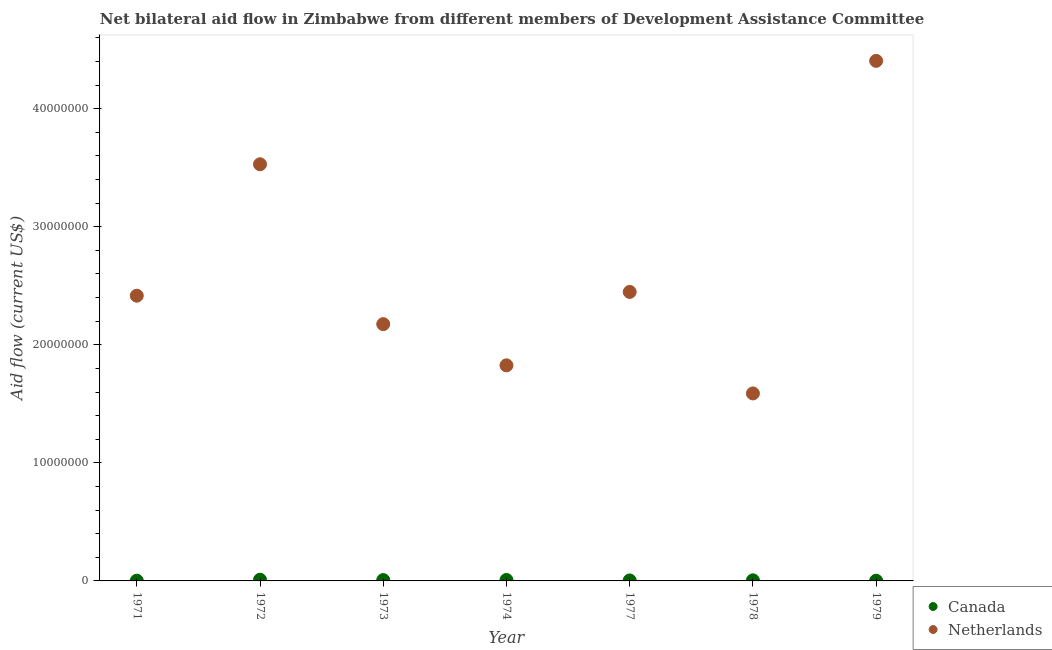What is the amount of aid given by netherlands in 1974?
Give a very brief answer. 1.83e+07. Across all years, what is the maximum amount of aid given by netherlands?
Ensure brevity in your answer.  4.40e+07. Across all years, what is the minimum amount of aid given by netherlands?
Provide a succinct answer. 1.59e+07. In which year was the amount of aid given by canada maximum?
Give a very brief answer. 1972. In which year was the amount of aid given by canada minimum?
Offer a terse response. 1971. What is the total amount of aid given by canada in the graph?
Provide a short and direct response. 3.80e+05. What is the difference between the amount of aid given by canada in 1972 and that in 1973?
Ensure brevity in your answer.  3.00e+04. What is the difference between the amount of aid given by netherlands in 1978 and the amount of aid given by canada in 1971?
Give a very brief answer. 1.59e+07. What is the average amount of aid given by canada per year?
Make the answer very short. 5.43e+04. In the year 1972, what is the difference between the amount of aid given by netherlands and amount of aid given by canada?
Provide a succinct answer. 3.52e+07. In how many years, is the amount of aid given by canada greater than 14000000 US$?
Your response must be concise. 0. What is the ratio of the amount of aid given by netherlands in 1971 to that in 1974?
Your answer should be compact. 1.32. Is the amount of aid given by netherlands in 1971 less than that in 1979?
Your response must be concise. Yes. What is the difference between the highest and the second highest amount of aid given by netherlands?
Your answer should be compact. 8.76e+06. What is the difference between the highest and the lowest amount of aid given by netherlands?
Provide a succinct answer. 2.82e+07. In how many years, is the amount of aid given by netherlands greater than the average amount of aid given by netherlands taken over all years?
Offer a very short reply. 2. Is the sum of the amount of aid given by canada in 1973 and 1977 greater than the maximum amount of aid given by netherlands across all years?
Provide a short and direct response. No. Does the amount of aid given by canada monotonically increase over the years?
Your answer should be very brief. No. Is the amount of aid given by netherlands strictly greater than the amount of aid given by canada over the years?
Provide a short and direct response. Yes. Is the amount of aid given by netherlands strictly less than the amount of aid given by canada over the years?
Your answer should be compact. No. How many dotlines are there?
Offer a terse response. 2. Where does the legend appear in the graph?
Offer a terse response. Bottom right. How many legend labels are there?
Keep it short and to the point. 2. What is the title of the graph?
Offer a very short reply. Net bilateral aid flow in Zimbabwe from different members of Development Assistance Committee. Does "Female" appear as one of the legend labels in the graph?
Keep it short and to the point. No. What is the Aid flow (current US$) of Canada in 1971?
Your answer should be compact. 2.00e+04. What is the Aid flow (current US$) of Netherlands in 1971?
Provide a succinct answer. 2.42e+07. What is the Aid flow (current US$) in Netherlands in 1972?
Provide a short and direct response. 3.53e+07. What is the Aid flow (current US$) in Canada in 1973?
Offer a terse response. 7.00e+04. What is the Aid flow (current US$) of Netherlands in 1973?
Your response must be concise. 2.18e+07. What is the Aid flow (current US$) of Netherlands in 1974?
Offer a very short reply. 1.83e+07. What is the Aid flow (current US$) in Canada in 1977?
Offer a terse response. 4.00e+04. What is the Aid flow (current US$) in Netherlands in 1977?
Offer a terse response. 2.45e+07. What is the Aid flow (current US$) of Netherlands in 1978?
Provide a short and direct response. 1.59e+07. What is the Aid flow (current US$) of Canada in 1979?
Provide a succinct answer. 2.00e+04. What is the Aid flow (current US$) of Netherlands in 1979?
Give a very brief answer. 4.40e+07. Across all years, what is the maximum Aid flow (current US$) of Netherlands?
Make the answer very short. 4.40e+07. Across all years, what is the minimum Aid flow (current US$) in Netherlands?
Provide a short and direct response. 1.59e+07. What is the total Aid flow (current US$) in Netherlands in the graph?
Keep it short and to the point. 1.84e+08. What is the difference between the Aid flow (current US$) of Canada in 1971 and that in 1972?
Provide a succinct answer. -8.00e+04. What is the difference between the Aid flow (current US$) of Netherlands in 1971 and that in 1972?
Your answer should be compact. -1.11e+07. What is the difference between the Aid flow (current US$) in Netherlands in 1971 and that in 1973?
Offer a terse response. 2.41e+06. What is the difference between the Aid flow (current US$) of Netherlands in 1971 and that in 1974?
Your response must be concise. 5.90e+06. What is the difference between the Aid flow (current US$) of Canada in 1971 and that in 1977?
Offer a terse response. -2.00e+04. What is the difference between the Aid flow (current US$) in Netherlands in 1971 and that in 1977?
Keep it short and to the point. -3.20e+05. What is the difference between the Aid flow (current US$) in Netherlands in 1971 and that in 1978?
Your answer should be compact. 8.28e+06. What is the difference between the Aid flow (current US$) in Canada in 1971 and that in 1979?
Make the answer very short. 0. What is the difference between the Aid flow (current US$) of Netherlands in 1971 and that in 1979?
Your response must be concise. -1.99e+07. What is the difference between the Aid flow (current US$) of Netherlands in 1972 and that in 1973?
Make the answer very short. 1.35e+07. What is the difference between the Aid flow (current US$) of Canada in 1972 and that in 1974?
Provide a succinct answer. 2.00e+04. What is the difference between the Aid flow (current US$) of Netherlands in 1972 and that in 1974?
Provide a succinct answer. 1.70e+07. What is the difference between the Aid flow (current US$) of Netherlands in 1972 and that in 1977?
Offer a terse response. 1.08e+07. What is the difference between the Aid flow (current US$) of Canada in 1972 and that in 1978?
Your response must be concise. 5.00e+04. What is the difference between the Aid flow (current US$) in Netherlands in 1972 and that in 1978?
Ensure brevity in your answer.  1.94e+07. What is the difference between the Aid flow (current US$) in Canada in 1972 and that in 1979?
Your response must be concise. 8.00e+04. What is the difference between the Aid flow (current US$) in Netherlands in 1972 and that in 1979?
Your response must be concise. -8.76e+06. What is the difference between the Aid flow (current US$) in Netherlands in 1973 and that in 1974?
Ensure brevity in your answer.  3.49e+06. What is the difference between the Aid flow (current US$) in Canada in 1973 and that in 1977?
Keep it short and to the point. 3.00e+04. What is the difference between the Aid flow (current US$) in Netherlands in 1973 and that in 1977?
Keep it short and to the point. -2.73e+06. What is the difference between the Aid flow (current US$) of Netherlands in 1973 and that in 1978?
Your answer should be compact. 5.87e+06. What is the difference between the Aid flow (current US$) in Netherlands in 1973 and that in 1979?
Your answer should be compact. -2.23e+07. What is the difference between the Aid flow (current US$) in Canada in 1974 and that in 1977?
Provide a short and direct response. 4.00e+04. What is the difference between the Aid flow (current US$) in Netherlands in 1974 and that in 1977?
Provide a short and direct response. -6.22e+06. What is the difference between the Aid flow (current US$) in Canada in 1974 and that in 1978?
Ensure brevity in your answer.  3.00e+04. What is the difference between the Aid flow (current US$) of Netherlands in 1974 and that in 1978?
Ensure brevity in your answer.  2.38e+06. What is the difference between the Aid flow (current US$) of Canada in 1974 and that in 1979?
Provide a succinct answer. 6.00e+04. What is the difference between the Aid flow (current US$) in Netherlands in 1974 and that in 1979?
Your answer should be very brief. -2.58e+07. What is the difference between the Aid flow (current US$) in Netherlands in 1977 and that in 1978?
Your answer should be very brief. 8.60e+06. What is the difference between the Aid flow (current US$) of Canada in 1977 and that in 1979?
Make the answer very short. 2.00e+04. What is the difference between the Aid flow (current US$) in Netherlands in 1977 and that in 1979?
Offer a terse response. -1.96e+07. What is the difference between the Aid flow (current US$) of Netherlands in 1978 and that in 1979?
Make the answer very short. -2.82e+07. What is the difference between the Aid flow (current US$) in Canada in 1971 and the Aid flow (current US$) in Netherlands in 1972?
Provide a short and direct response. -3.53e+07. What is the difference between the Aid flow (current US$) of Canada in 1971 and the Aid flow (current US$) of Netherlands in 1973?
Your answer should be very brief. -2.17e+07. What is the difference between the Aid flow (current US$) of Canada in 1971 and the Aid flow (current US$) of Netherlands in 1974?
Offer a terse response. -1.82e+07. What is the difference between the Aid flow (current US$) in Canada in 1971 and the Aid flow (current US$) in Netherlands in 1977?
Your response must be concise. -2.45e+07. What is the difference between the Aid flow (current US$) in Canada in 1971 and the Aid flow (current US$) in Netherlands in 1978?
Make the answer very short. -1.59e+07. What is the difference between the Aid flow (current US$) in Canada in 1971 and the Aid flow (current US$) in Netherlands in 1979?
Your response must be concise. -4.40e+07. What is the difference between the Aid flow (current US$) of Canada in 1972 and the Aid flow (current US$) of Netherlands in 1973?
Provide a succinct answer. -2.16e+07. What is the difference between the Aid flow (current US$) in Canada in 1972 and the Aid flow (current US$) in Netherlands in 1974?
Provide a succinct answer. -1.82e+07. What is the difference between the Aid flow (current US$) of Canada in 1972 and the Aid flow (current US$) of Netherlands in 1977?
Provide a succinct answer. -2.44e+07. What is the difference between the Aid flow (current US$) in Canada in 1972 and the Aid flow (current US$) in Netherlands in 1978?
Provide a succinct answer. -1.58e+07. What is the difference between the Aid flow (current US$) in Canada in 1972 and the Aid flow (current US$) in Netherlands in 1979?
Provide a short and direct response. -4.40e+07. What is the difference between the Aid flow (current US$) of Canada in 1973 and the Aid flow (current US$) of Netherlands in 1974?
Ensure brevity in your answer.  -1.82e+07. What is the difference between the Aid flow (current US$) in Canada in 1973 and the Aid flow (current US$) in Netherlands in 1977?
Your answer should be very brief. -2.44e+07. What is the difference between the Aid flow (current US$) of Canada in 1973 and the Aid flow (current US$) of Netherlands in 1978?
Provide a short and direct response. -1.58e+07. What is the difference between the Aid flow (current US$) in Canada in 1973 and the Aid flow (current US$) in Netherlands in 1979?
Provide a short and direct response. -4.40e+07. What is the difference between the Aid flow (current US$) in Canada in 1974 and the Aid flow (current US$) in Netherlands in 1977?
Provide a succinct answer. -2.44e+07. What is the difference between the Aid flow (current US$) in Canada in 1974 and the Aid flow (current US$) in Netherlands in 1978?
Offer a very short reply. -1.58e+07. What is the difference between the Aid flow (current US$) of Canada in 1974 and the Aid flow (current US$) of Netherlands in 1979?
Offer a very short reply. -4.40e+07. What is the difference between the Aid flow (current US$) of Canada in 1977 and the Aid flow (current US$) of Netherlands in 1978?
Ensure brevity in your answer.  -1.58e+07. What is the difference between the Aid flow (current US$) of Canada in 1977 and the Aid flow (current US$) of Netherlands in 1979?
Your answer should be very brief. -4.40e+07. What is the difference between the Aid flow (current US$) of Canada in 1978 and the Aid flow (current US$) of Netherlands in 1979?
Provide a short and direct response. -4.40e+07. What is the average Aid flow (current US$) in Canada per year?
Ensure brevity in your answer.  5.43e+04. What is the average Aid flow (current US$) of Netherlands per year?
Make the answer very short. 2.63e+07. In the year 1971, what is the difference between the Aid flow (current US$) of Canada and Aid flow (current US$) of Netherlands?
Offer a terse response. -2.41e+07. In the year 1972, what is the difference between the Aid flow (current US$) of Canada and Aid flow (current US$) of Netherlands?
Provide a short and direct response. -3.52e+07. In the year 1973, what is the difference between the Aid flow (current US$) in Canada and Aid flow (current US$) in Netherlands?
Ensure brevity in your answer.  -2.17e+07. In the year 1974, what is the difference between the Aid flow (current US$) in Canada and Aid flow (current US$) in Netherlands?
Keep it short and to the point. -1.82e+07. In the year 1977, what is the difference between the Aid flow (current US$) of Canada and Aid flow (current US$) of Netherlands?
Give a very brief answer. -2.44e+07. In the year 1978, what is the difference between the Aid flow (current US$) of Canada and Aid flow (current US$) of Netherlands?
Your answer should be very brief. -1.58e+07. In the year 1979, what is the difference between the Aid flow (current US$) of Canada and Aid flow (current US$) of Netherlands?
Provide a short and direct response. -4.40e+07. What is the ratio of the Aid flow (current US$) in Netherlands in 1971 to that in 1972?
Your answer should be compact. 0.68. What is the ratio of the Aid flow (current US$) in Canada in 1971 to that in 1973?
Your response must be concise. 0.29. What is the ratio of the Aid flow (current US$) in Netherlands in 1971 to that in 1973?
Your response must be concise. 1.11. What is the ratio of the Aid flow (current US$) of Netherlands in 1971 to that in 1974?
Provide a succinct answer. 1.32. What is the ratio of the Aid flow (current US$) of Netherlands in 1971 to that in 1977?
Ensure brevity in your answer.  0.99. What is the ratio of the Aid flow (current US$) of Canada in 1971 to that in 1978?
Keep it short and to the point. 0.4. What is the ratio of the Aid flow (current US$) in Netherlands in 1971 to that in 1978?
Your answer should be compact. 1.52. What is the ratio of the Aid flow (current US$) in Netherlands in 1971 to that in 1979?
Offer a very short reply. 0.55. What is the ratio of the Aid flow (current US$) in Canada in 1972 to that in 1973?
Your answer should be compact. 1.43. What is the ratio of the Aid flow (current US$) of Netherlands in 1972 to that in 1973?
Your response must be concise. 1.62. What is the ratio of the Aid flow (current US$) in Canada in 1972 to that in 1974?
Offer a terse response. 1.25. What is the ratio of the Aid flow (current US$) of Netherlands in 1972 to that in 1974?
Give a very brief answer. 1.93. What is the ratio of the Aid flow (current US$) of Canada in 1972 to that in 1977?
Keep it short and to the point. 2.5. What is the ratio of the Aid flow (current US$) of Netherlands in 1972 to that in 1977?
Give a very brief answer. 1.44. What is the ratio of the Aid flow (current US$) of Canada in 1972 to that in 1978?
Your response must be concise. 2. What is the ratio of the Aid flow (current US$) of Netherlands in 1972 to that in 1978?
Your answer should be very brief. 2.22. What is the ratio of the Aid flow (current US$) in Canada in 1972 to that in 1979?
Provide a short and direct response. 5. What is the ratio of the Aid flow (current US$) of Netherlands in 1972 to that in 1979?
Give a very brief answer. 0.8. What is the ratio of the Aid flow (current US$) of Canada in 1973 to that in 1974?
Make the answer very short. 0.88. What is the ratio of the Aid flow (current US$) in Netherlands in 1973 to that in 1974?
Your answer should be compact. 1.19. What is the ratio of the Aid flow (current US$) in Netherlands in 1973 to that in 1977?
Ensure brevity in your answer.  0.89. What is the ratio of the Aid flow (current US$) in Netherlands in 1973 to that in 1978?
Your response must be concise. 1.37. What is the ratio of the Aid flow (current US$) of Netherlands in 1973 to that in 1979?
Your answer should be compact. 0.49. What is the ratio of the Aid flow (current US$) in Netherlands in 1974 to that in 1977?
Your answer should be compact. 0.75. What is the ratio of the Aid flow (current US$) of Canada in 1974 to that in 1978?
Make the answer very short. 1.6. What is the ratio of the Aid flow (current US$) of Netherlands in 1974 to that in 1978?
Give a very brief answer. 1.15. What is the ratio of the Aid flow (current US$) of Netherlands in 1974 to that in 1979?
Provide a short and direct response. 0.41. What is the ratio of the Aid flow (current US$) in Canada in 1977 to that in 1978?
Make the answer very short. 0.8. What is the ratio of the Aid flow (current US$) in Netherlands in 1977 to that in 1978?
Your answer should be compact. 1.54. What is the ratio of the Aid flow (current US$) of Canada in 1977 to that in 1979?
Offer a terse response. 2. What is the ratio of the Aid flow (current US$) of Netherlands in 1977 to that in 1979?
Your answer should be compact. 0.56. What is the ratio of the Aid flow (current US$) in Canada in 1978 to that in 1979?
Keep it short and to the point. 2.5. What is the ratio of the Aid flow (current US$) in Netherlands in 1978 to that in 1979?
Keep it short and to the point. 0.36. What is the difference between the highest and the second highest Aid flow (current US$) in Netherlands?
Provide a succinct answer. 8.76e+06. What is the difference between the highest and the lowest Aid flow (current US$) of Netherlands?
Your answer should be compact. 2.82e+07. 